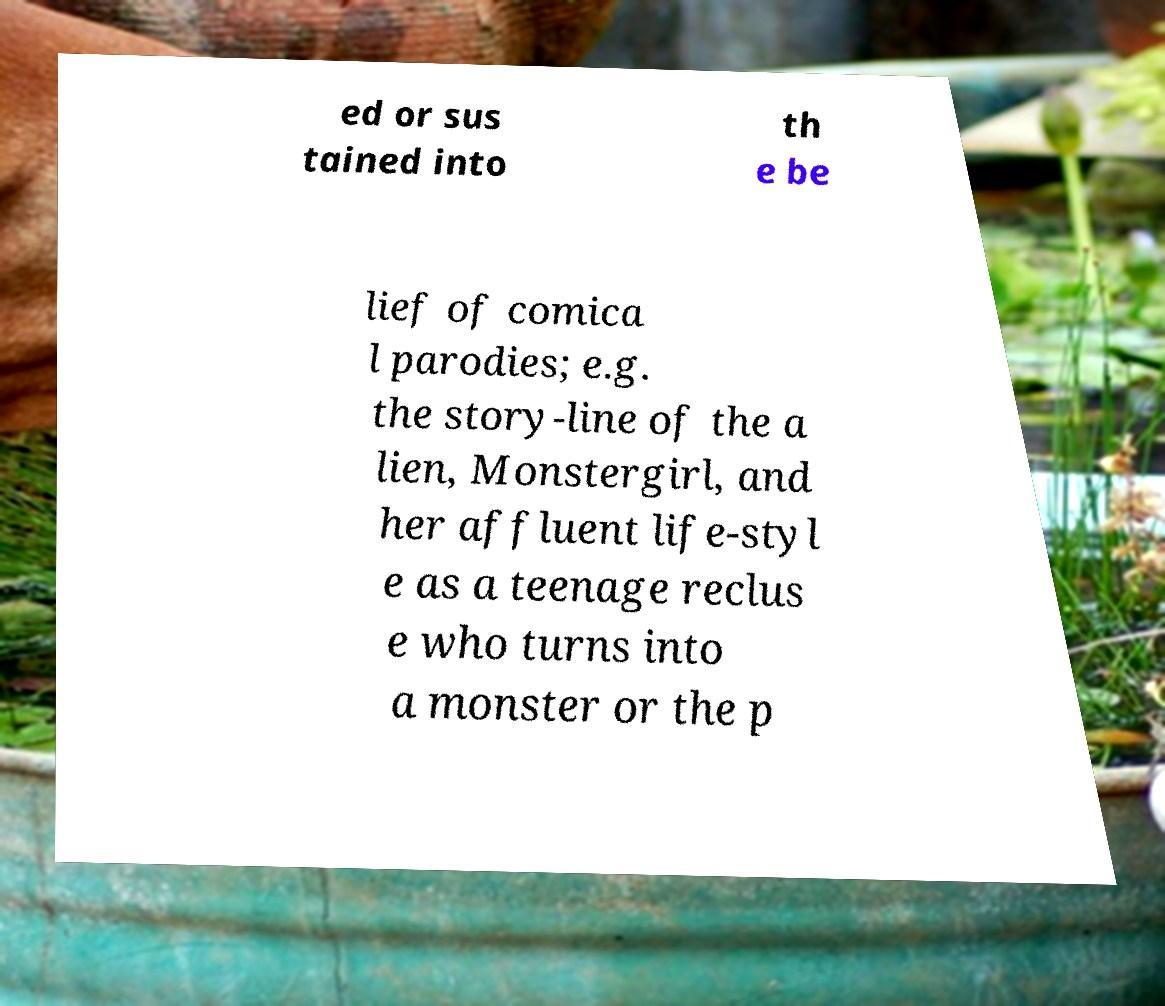Can you accurately transcribe the text from the provided image for me? ed or sus tained into th e be lief of comica l parodies; e.g. the story-line of the a lien, Monstergirl, and her affluent life-styl e as a teenage reclus e who turns into a monster or the p 